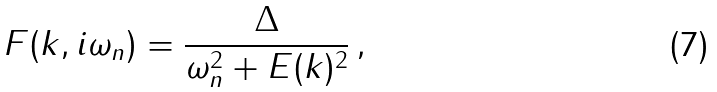<formula> <loc_0><loc_0><loc_500><loc_500>\, F ( { k } , i \omega _ { n } ) = \frac { \Delta } { \omega _ { n } ^ { 2 } + E ( { k } ) ^ { 2 } } \, ,</formula> 